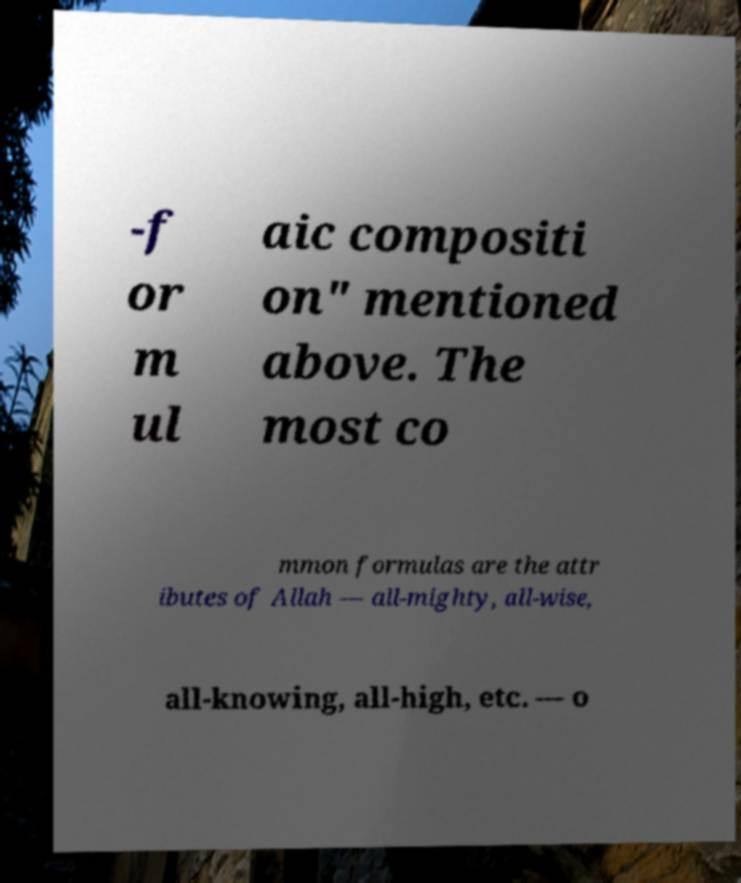For documentation purposes, I need the text within this image transcribed. Could you provide that? -f or m ul aic compositi on" mentioned above. The most co mmon formulas are the attr ibutes of Allah — all-mighty, all-wise, all-knowing, all-high, etc. — o 